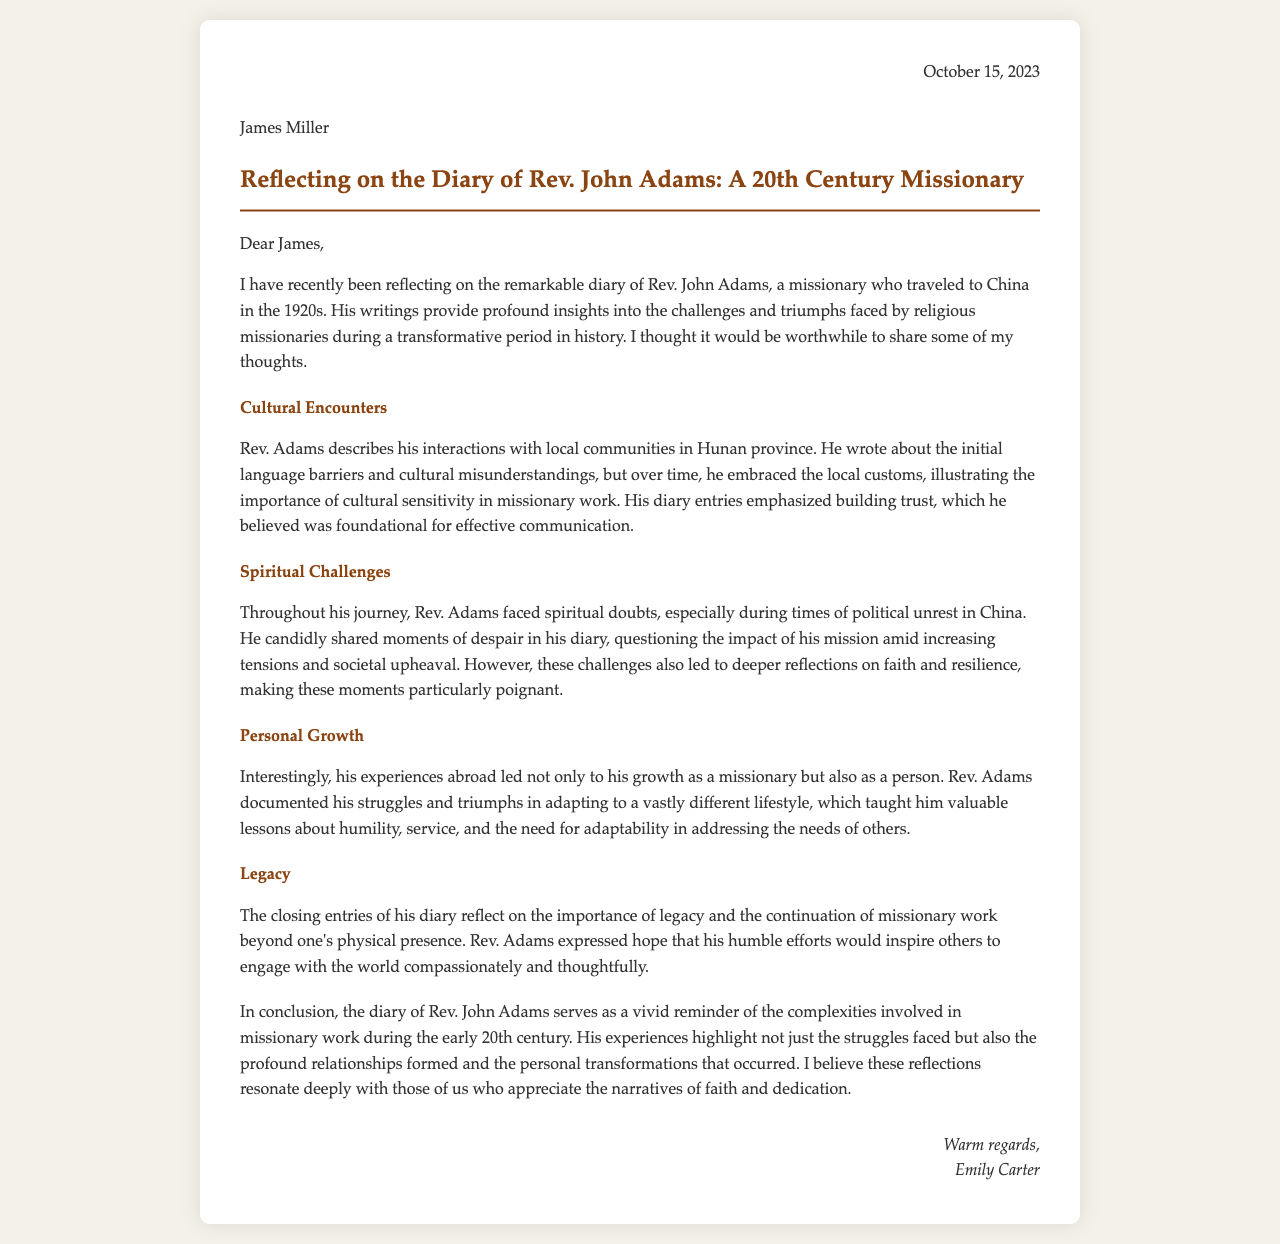What year did Rev. John Adams travel to China? The document states that Rev. Adams traveled to China in the 1920s.
Answer: 1920s What province in China did Rev. John Adams primarily work? The diary mentions that he interacted with local communities in Hunan province.
Answer: Hunan Who is the recipient of the letter? The letter is addressed to James Miller.
Answer: James Miller What is one of the spiritual challenges mentioned in Rev. Adams' diary? Rev. Adams candidly shared moments of despair during times of political unrest in China.
Answer: Political unrest What lesson about missionary work does Rev. Adams emphasize in his diary? Rev. Adams highlights the importance of cultural sensitivity in missionary work.
Answer: Cultural sensitivity What does Rev. Adams express hope for in his closing entries? He expresses hope that his efforts would inspire others to engage with the world compassionately.
Answer: Inspire others What is the main theme of the personal growth described in Rev. Adams’ accounts? Rev. Adams’ experiences taught him valuable lessons about humility, service, and adaptability.
Answer: Humility, service, adaptability Who is the author of the letter reflecting on Rev. John Adams' diary? The letter is authored by Emily Carter.
Answer: Emily Carter What type of work does Rev. Adams engage in during his time abroad? He worked as a missionary.
Answer: Missionary 